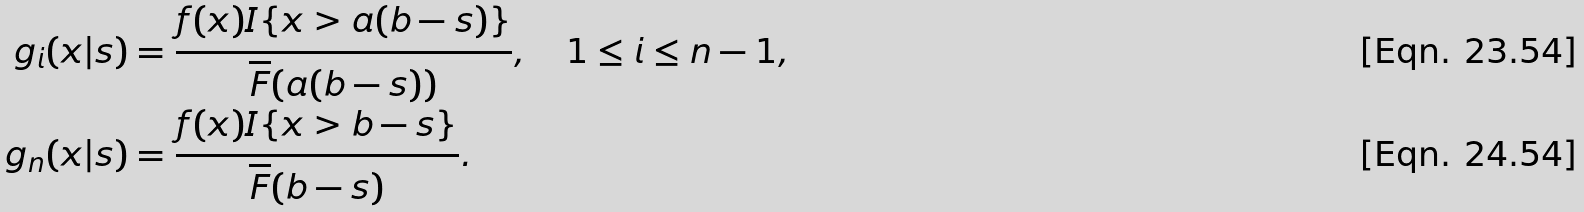<formula> <loc_0><loc_0><loc_500><loc_500>g _ { i } ( x | s ) & = \frac { f ( x ) I \{ x > a ( b - s ) \} } { \overline { F } ( a ( b - s ) ) } , \quad 1 \leq i \leq n - 1 , \\ g _ { n } ( x | s ) & = \frac { f ( x ) I \{ x > b - s \} } { \overline { F } ( b - s ) } .</formula> 